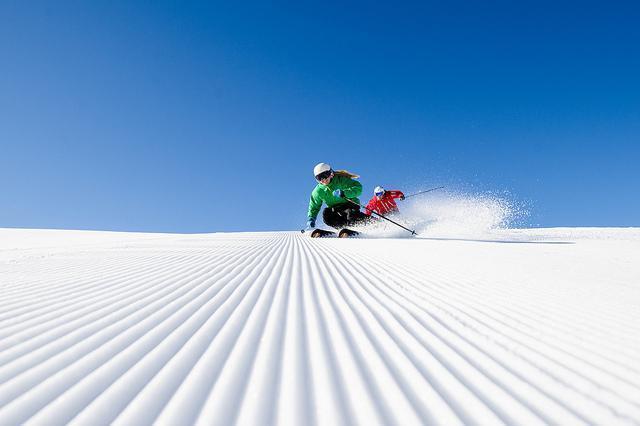How many people are in this photo?
Give a very brief answer. 2. 